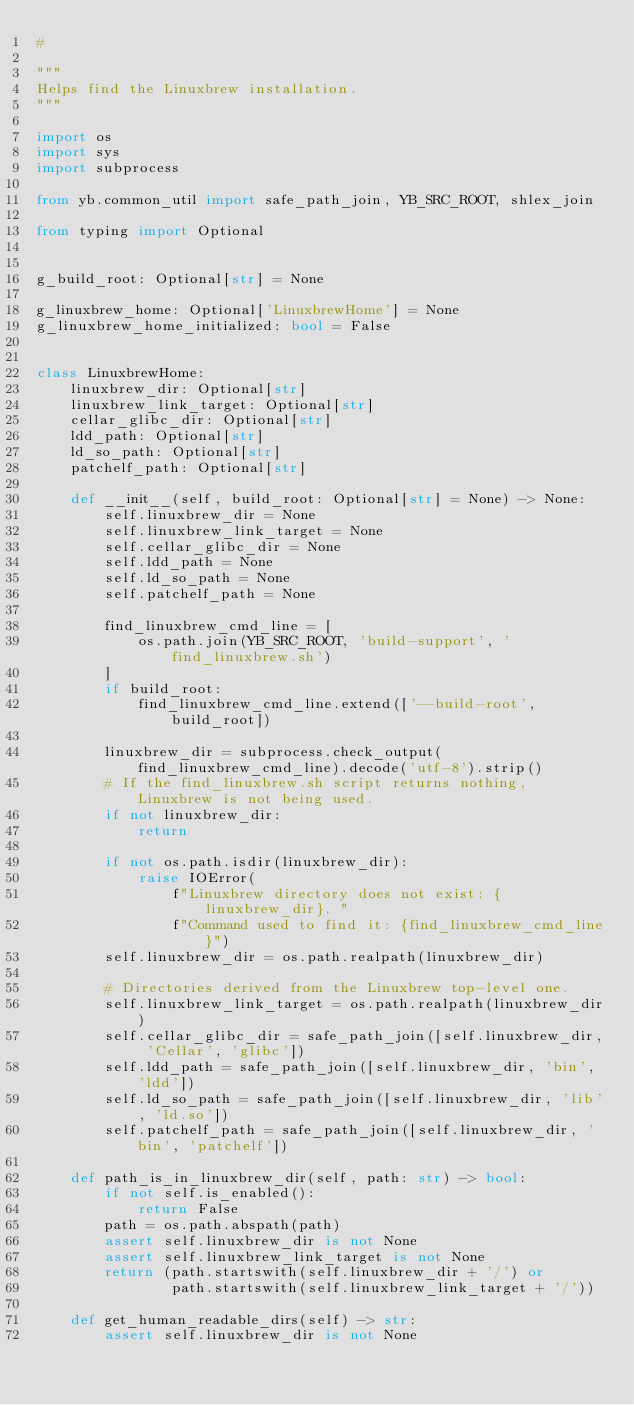<code> <loc_0><loc_0><loc_500><loc_500><_Python_>#

"""
Helps find the Linuxbrew installation.
"""

import os
import sys
import subprocess

from yb.common_util import safe_path_join, YB_SRC_ROOT, shlex_join

from typing import Optional


g_build_root: Optional[str] = None

g_linuxbrew_home: Optional['LinuxbrewHome'] = None
g_linuxbrew_home_initialized: bool = False


class LinuxbrewHome:
    linuxbrew_dir: Optional[str]
    linuxbrew_link_target: Optional[str]
    cellar_glibc_dir: Optional[str]
    ldd_path: Optional[str]
    ld_so_path: Optional[str]
    patchelf_path: Optional[str]

    def __init__(self, build_root: Optional[str] = None) -> None:
        self.linuxbrew_dir = None
        self.linuxbrew_link_target = None
        self.cellar_glibc_dir = None
        self.ldd_path = None
        self.ld_so_path = None
        self.patchelf_path = None

        find_linuxbrew_cmd_line = [
            os.path.join(YB_SRC_ROOT, 'build-support', 'find_linuxbrew.sh')
        ]
        if build_root:
            find_linuxbrew_cmd_line.extend(['--build-root', build_root])

        linuxbrew_dir = subprocess.check_output(find_linuxbrew_cmd_line).decode('utf-8').strip()
        # If the find_linuxbrew.sh script returns nothing, Linuxbrew is not being used.
        if not linuxbrew_dir:
            return

        if not os.path.isdir(linuxbrew_dir):
            raise IOError(
                f"Linuxbrew directory does not exist: {linuxbrew_dir}. "
                f"Command used to find it: {find_linuxbrew_cmd_line}")
        self.linuxbrew_dir = os.path.realpath(linuxbrew_dir)

        # Directories derived from the Linuxbrew top-level one.
        self.linuxbrew_link_target = os.path.realpath(linuxbrew_dir)
        self.cellar_glibc_dir = safe_path_join([self.linuxbrew_dir, 'Cellar', 'glibc'])
        self.ldd_path = safe_path_join([self.linuxbrew_dir, 'bin', 'ldd'])
        self.ld_so_path = safe_path_join([self.linuxbrew_dir, 'lib', 'ld.so'])
        self.patchelf_path = safe_path_join([self.linuxbrew_dir, 'bin', 'patchelf'])

    def path_is_in_linuxbrew_dir(self, path: str) -> bool:
        if not self.is_enabled():
            return False
        path = os.path.abspath(path)
        assert self.linuxbrew_dir is not None
        assert self.linuxbrew_link_target is not None
        return (path.startswith(self.linuxbrew_dir + '/') or
                path.startswith(self.linuxbrew_link_target + '/'))

    def get_human_readable_dirs(self) -> str:
        assert self.linuxbrew_dir is not None</code> 